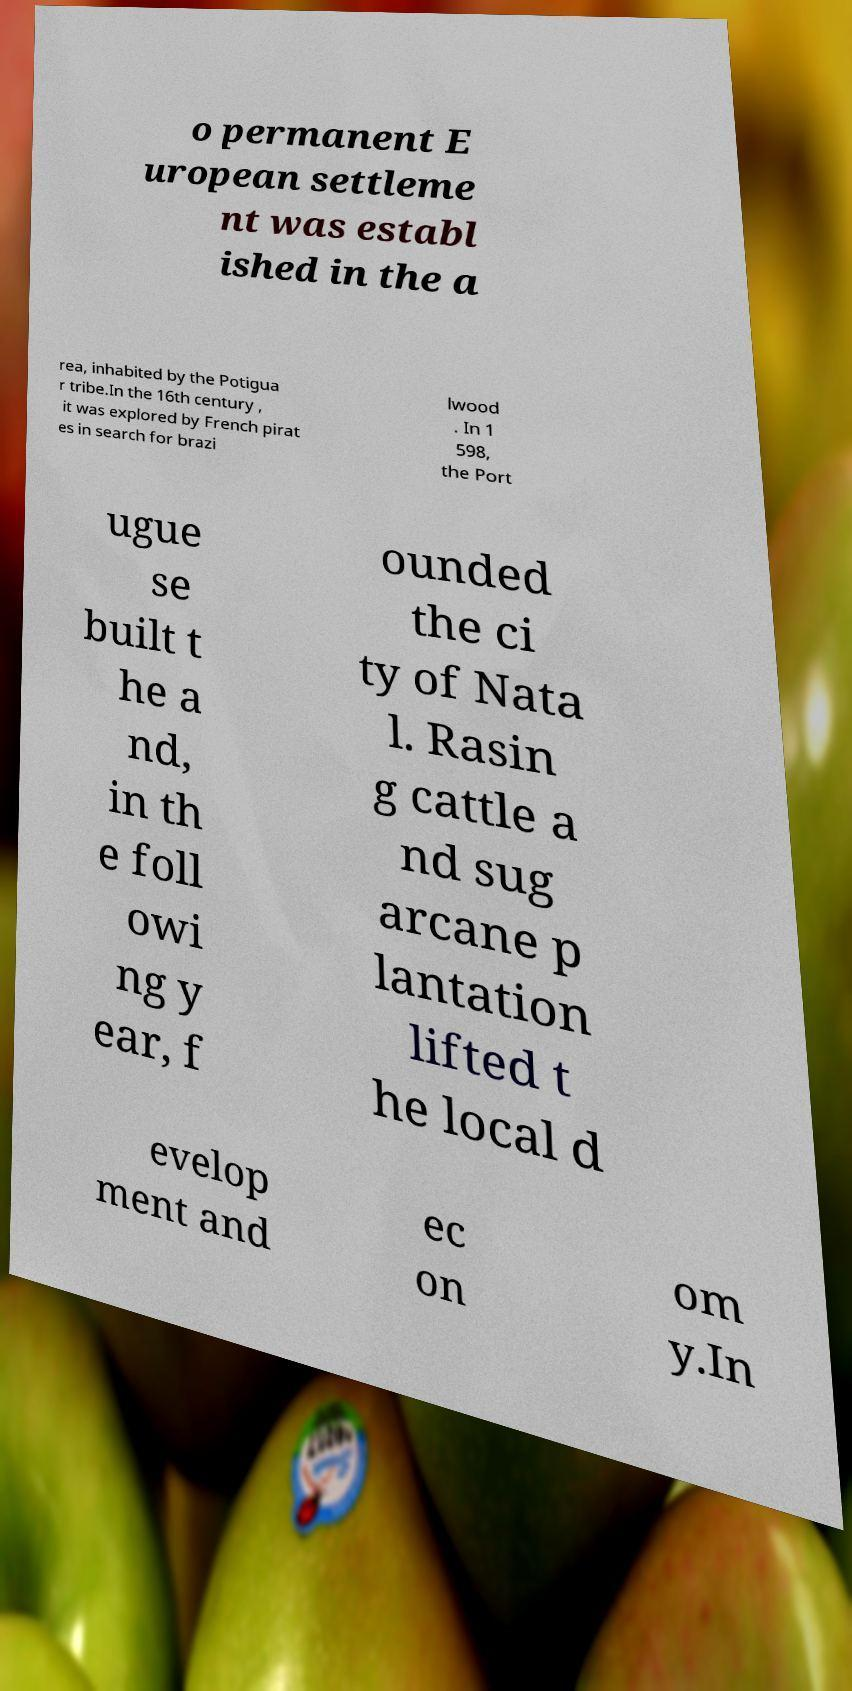Please read and relay the text visible in this image. What does it say? o permanent E uropean settleme nt was establ ished in the a rea, inhabited by the Potigua r tribe.In the 16th century , it was explored by French pirat es in search for brazi lwood . In 1 598, the Port ugue se built t he a nd, in th e foll owi ng y ear, f ounded the ci ty of Nata l. Rasin g cattle a nd sug arcane p lantation lifted t he local d evelop ment and ec on om y.In 